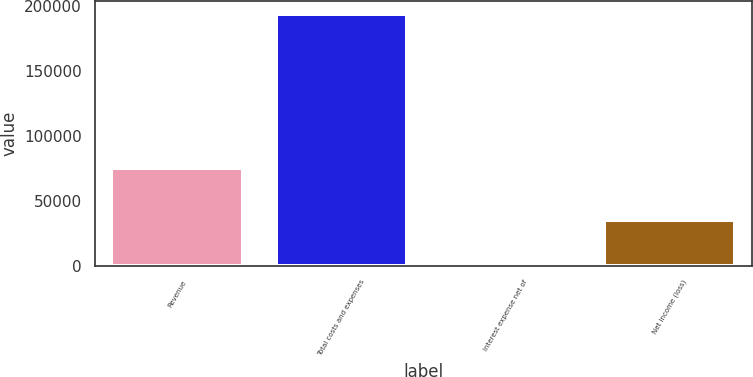Convert chart. <chart><loc_0><loc_0><loc_500><loc_500><bar_chart><fcel>Revenue<fcel>Total costs and expenses<fcel>Interest expense net of<fcel>Net income (loss)<nl><fcel>75589<fcel>194363<fcel>438<fcel>35637<nl></chart> 